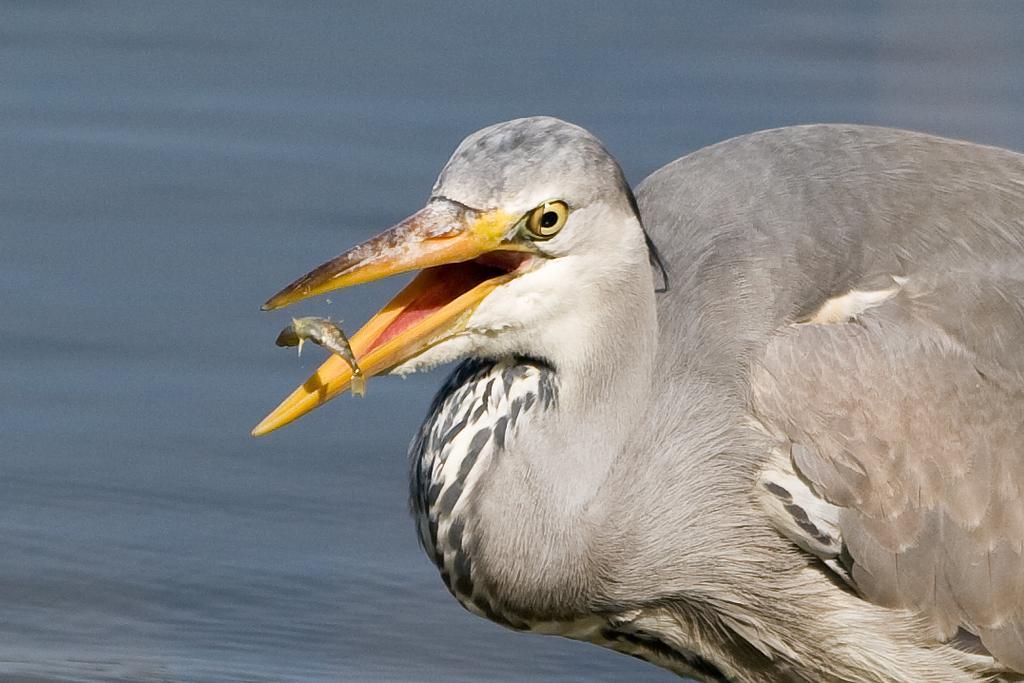How would you summarize this image in a sentence or two? In the foreground of the image there is a bird. There is a fish. In the background of the image there is water. 